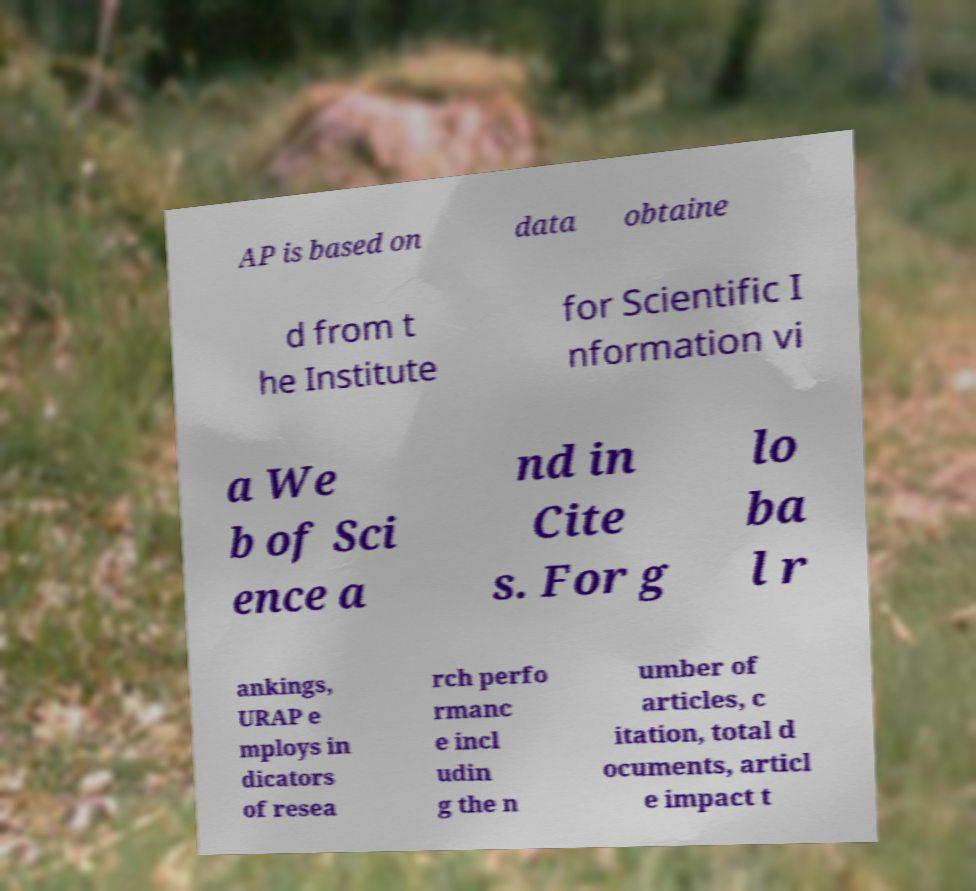There's text embedded in this image that I need extracted. Can you transcribe it verbatim? AP is based on data obtaine d from t he Institute for Scientific I nformation vi a We b of Sci ence a nd in Cite s. For g lo ba l r ankings, URAP e mploys in dicators of resea rch perfo rmanc e incl udin g the n umber of articles, c itation, total d ocuments, articl e impact t 